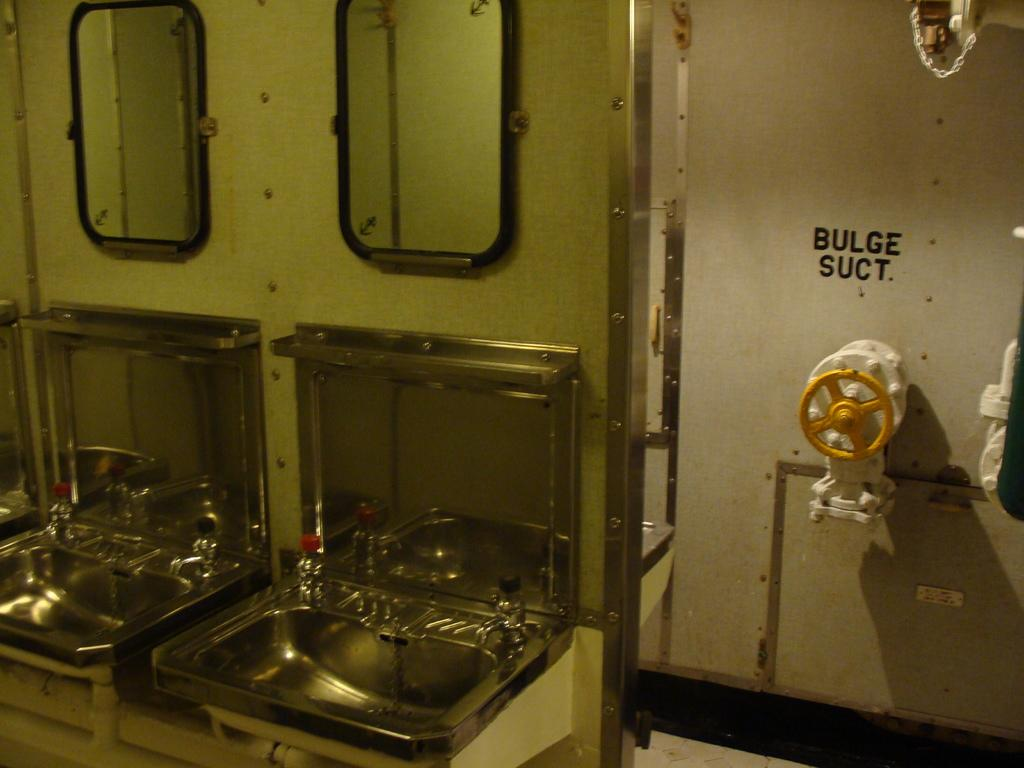<image>
Present a compact description of the photo's key features. Two sinks are on the left wall while the right side of the wall shows a sign for Bulge Suct. 